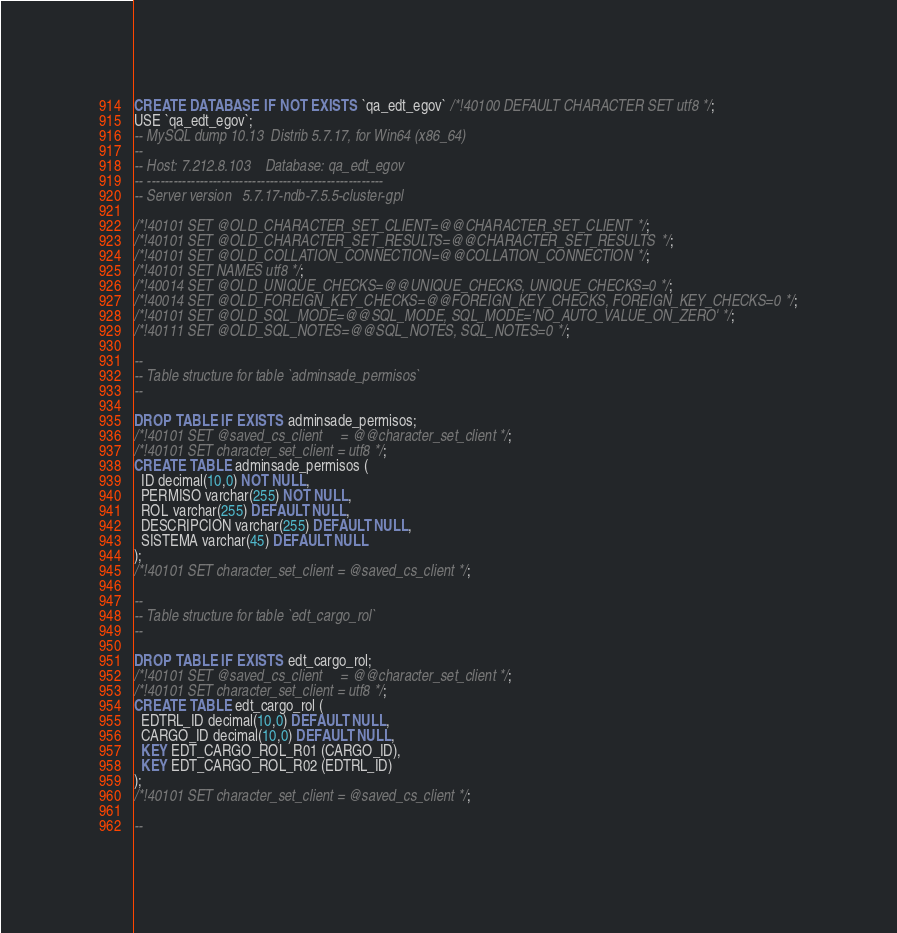<code> <loc_0><loc_0><loc_500><loc_500><_SQL_>CREATE DATABASE  IF NOT EXISTS `qa_edt_egov` /*!40100 DEFAULT CHARACTER SET utf8 */;
USE `qa_edt_egov`;
-- MySQL dump 10.13  Distrib 5.7.17, for Win64 (x86_64)
--
-- Host: 7.212.8.103    Database: qa_edt_egov
-- ------------------------------------------------------
-- Server version	5.7.17-ndb-7.5.5-cluster-gpl

/*!40101 SET @OLD_CHARACTER_SET_CLIENT=@@CHARACTER_SET_CLIENT */;
/*!40101 SET @OLD_CHARACTER_SET_RESULTS=@@CHARACTER_SET_RESULTS */;
/*!40101 SET @OLD_COLLATION_CONNECTION=@@COLLATION_CONNECTION */;
/*!40101 SET NAMES utf8 */;
/*!40014 SET @OLD_UNIQUE_CHECKS=@@UNIQUE_CHECKS, UNIQUE_CHECKS=0 */;
/*!40014 SET @OLD_FOREIGN_KEY_CHECKS=@@FOREIGN_KEY_CHECKS, FOREIGN_KEY_CHECKS=0 */;
/*!40101 SET @OLD_SQL_MODE=@@SQL_MODE, SQL_MODE='NO_AUTO_VALUE_ON_ZERO' */;
/*!40111 SET @OLD_SQL_NOTES=@@SQL_NOTES, SQL_NOTES=0 */;

--
-- Table structure for table `adminsade_permisos`
--

DROP TABLE IF EXISTS adminsade_permisos;
/*!40101 SET @saved_cs_client     = @@character_set_client */;
/*!40101 SET character_set_client = utf8 */;
CREATE TABLE adminsade_permisos (
  ID decimal(10,0) NOT NULL,
  PERMISO varchar(255) NOT NULL,
  ROL varchar(255) DEFAULT NULL,
  DESCRIPCION varchar(255) DEFAULT NULL,
  SISTEMA varchar(45) DEFAULT NULL
);
/*!40101 SET character_set_client = @saved_cs_client */;

--
-- Table structure for table `edt_cargo_rol`
--

DROP TABLE IF EXISTS edt_cargo_rol;
/*!40101 SET @saved_cs_client     = @@character_set_client */;
/*!40101 SET character_set_client = utf8 */;
CREATE TABLE edt_cargo_rol (
  EDTRL_ID decimal(10,0) DEFAULT NULL,
  CARGO_ID decimal(10,0) DEFAULT NULL,
  KEY EDT_CARGO_ROL_R01 (CARGO_ID),
  KEY EDT_CARGO_ROL_R02 (EDTRL_ID)
);
/*!40101 SET character_set_client = @saved_cs_client */;

--</code> 